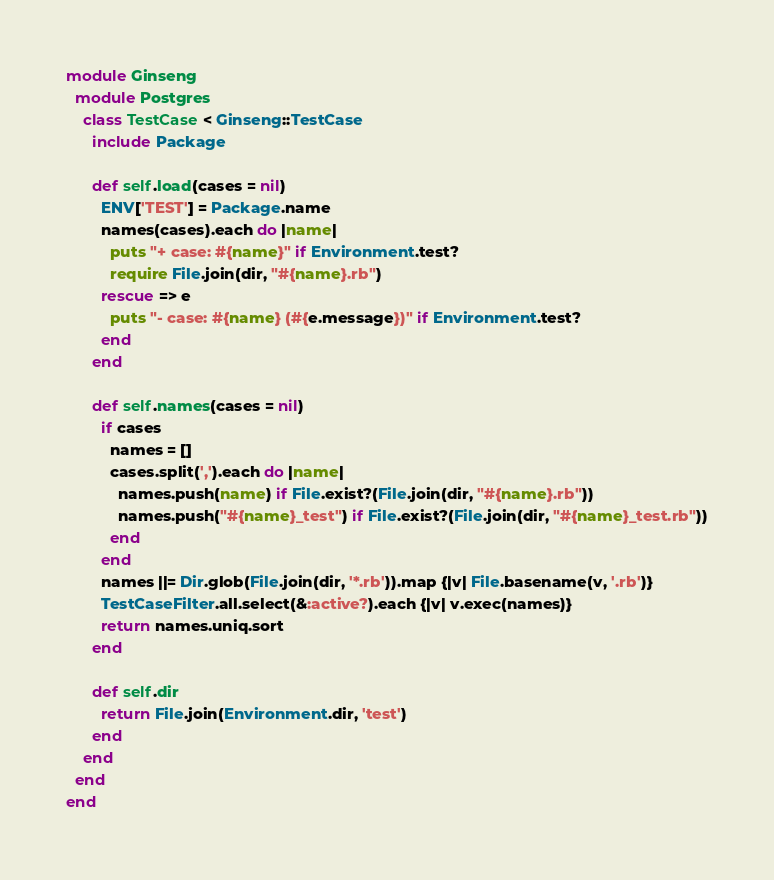<code> <loc_0><loc_0><loc_500><loc_500><_Ruby_>module Ginseng
  module Postgres
    class TestCase < Ginseng::TestCase
      include Package

      def self.load(cases = nil)
        ENV['TEST'] = Package.name
        names(cases).each do |name|
          puts "+ case: #{name}" if Environment.test?
          require File.join(dir, "#{name}.rb")
        rescue => e
          puts "- case: #{name} (#{e.message})" if Environment.test?
        end
      end

      def self.names(cases = nil)
        if cases
          names = []
          cases.split(',').each do |name|
            names.push(name) if File.exist?(File.join(dir, "#{name}.rb"))
            names.push("#{name}_test") if File.exist?(File.join(dir, "#{name}_test.rb"))
          end
        end
        names ||= Dir.glob(File.join(dir, '*.rb')).map {|v| File.basename(v, '.rb')}
        TestCaseFilter.all.select(&:active?).each {|v| v.exec(names)}
        return names.uniq.sort
      end

      def self.dir
        return File.join(Environment.dir, 'test')
      end
    end
  end
end
</code> 